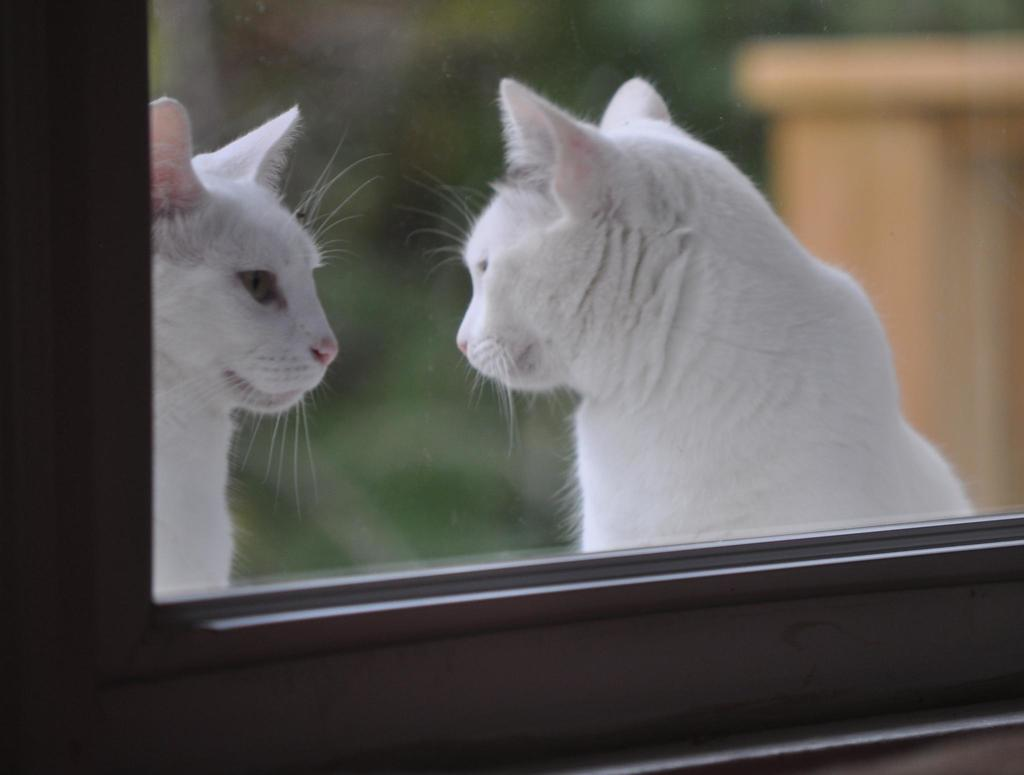What type of structure is present in the image? There is a glass window in the image. What can be seen behind the glass? There are two white color cats behind the glass. What are the cats doing in the image? The cats are looking at each other. What is located on the right side of the image? There is a wooden object on the right side of the image. How would you describe the background of the image? The background of the image is blurred. What type of vegetable is being harvested in the image? There is no vegetable or harvesting activity present in the image. What kind of operation is being performed on the cats in the image? There is no operation or medical procedure being performed on the cats in the image. 